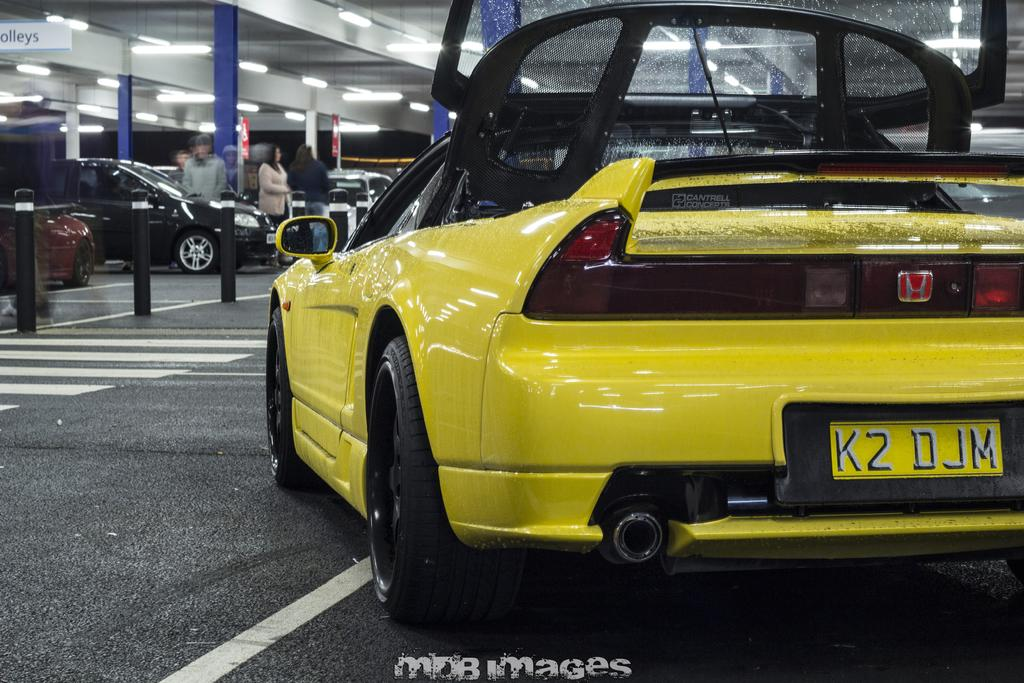What type of vehicles can be seen in the image? There are cars in the image. Can you describe the people in the image? There is a group of people in the image. What material are the rods made of in the image? The rods in the image are made of metal. What can be seen illuminating the scene in the image? There are lights in the image. Where is the watermark located in the image? The watermark is at the middle bottom of the image. What riddle is being solved by the group of people in the image? There is no riddle being solved by the group of people in the image; they are simply present in the scene. What language are the people in the image speaking? The language being spoken by the people in the image cannot be determined from the image alone. 